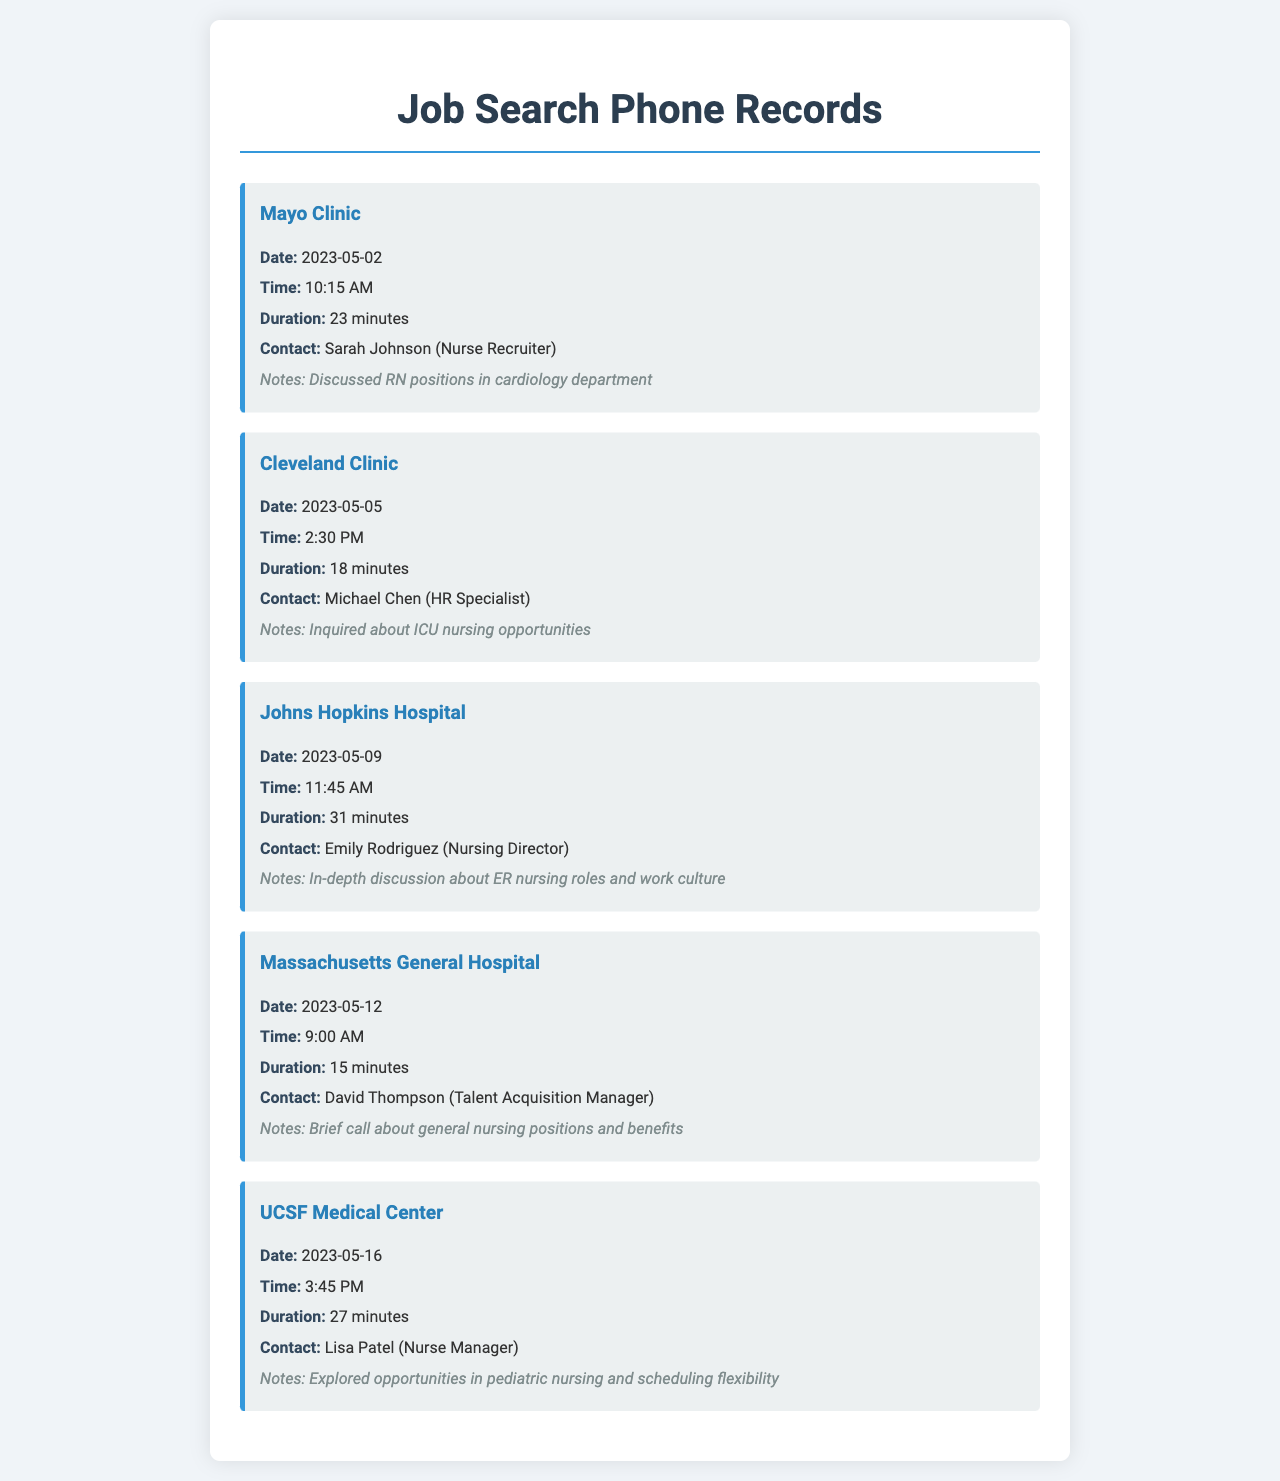what is the date of the call with Mayo Clinic? The date of the call with Mayo Clinic is clearly listed in the document under the Mayo Clinic entry.
Answer: 2023-05-02 who was the contact for the call with UCSF Medical Center? The document specifies the contact name for the UCSF Medical Center call.
Answer: Lisa Patel how long was the conversation with Johns Hopkins Hospital? The duration of the call is provided in the document for each entry.
Answer: 31 minutes which healthcare facility did the call mention discussing pediatric nursing? The document specifically notes the type of nursing discussed during the call with UCSF Medical Center.
Answer: UCSF Medical Center how many minutes was the call with Massachusetts General Hospital? The document includes the duration for each call, including the one with Massachusetts General Hospital.
Answer: 15 minutes who was contacted at Cleveland Clinic? The contact person’s name is provided in the Cleveland Clinic entry.
Answer: Michael Chen what was the main focus of the call with Johns Hopkins Hospital? The call details for Johns Hopkins Hospital include a mention of the focus of the discussion.
Answer: ER nursing roles and work culture which hospital had the shortest call duration? By examining the durations listed for each facility, one can identify the shortest call.
Answer: Massachusetts General Hospital how many calls were made in total according to the document? The total number of entries in the document represents the total calls made.
Answer: 5 